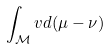Convert formula to latex. <formula><loc_0><loc_0><loc_500><loc_500>\int _ { \mathcal { M } } v d ( \mu - \nu )</formula> 